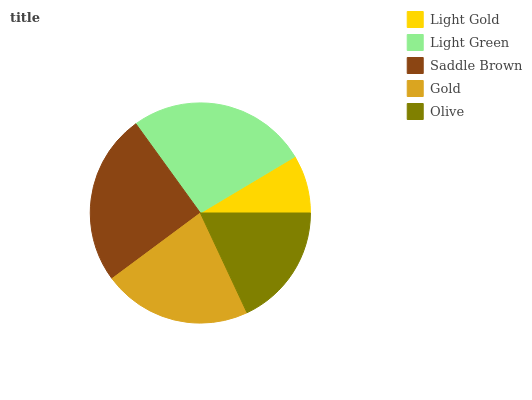Is Light Gold the minimum?
Answer yes or no. Yes. Is Light Green the maximum?
Answer yes or no. Yes. Is Saddle Brown the minimum?
Answer yes or no. No. Is Saddle Brown the maximum?
Answer yes or no. No. Is Light Green greater than Saddle Brown?
Answer yes or no. Yes. Is Saddle Brown less than Light Green?
Answer yes or no. Yes. Is Saddle Brown greater than Light Green?
Answer yes or no. No. Is Light Green less than Saddle Brown?
Answer yes or no. No. Is Gold the high median?
Answer yes or no. Yes. Is Gold the low median?
Answer yes or no. Yes. Is Saddle Brown the high median?
Answer yes or no. No. Is Light Green the low median?
Answer yes or no. No. 